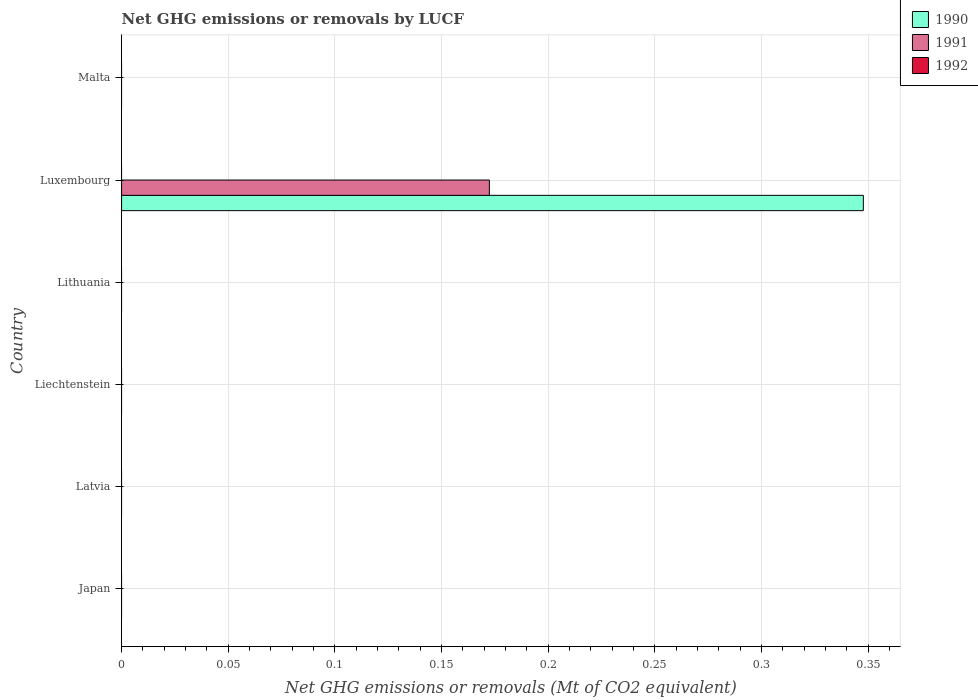Are the number of bars on each tick of the Y-axis equal?
Your response must be concise. No. How many bars are there on the 5th tick from the top?
Provide a short and direct response. 0. How many bars are there on the 6th tick from the bottom?
Keep it short and to the point. 0. What is the label of the 5th group of bars from the top?
Your answer should be compact. Latvia. In how many cases, is the number of bars for a given country not equal to the number of legend labels?
Your response must be concise. 6. What is the net GHG emissions or removals by LUCF in 1992 in Malta?
Your answer should be compact. 0. Across all countries, what is the maximum net GHG emissions or removals by LUCF in 1990?
Your answer should be very brief. 0.35. In which country was the net GHG emissions or removals by LUCF in 1990 maximum?
Your answer should be compact. Luxembourg. What is the total net GHG emissions or removals by LUCF in 1991 in the graph?
Provide a short and direct response. 0.17. What is the difference between the net GHG emissions or removals by LUCF in 1990 in Luxembourg and the net GHG emissions or removals by LUCF in 1992 in Malta?
Offer a very short reply. 0.35. What is the average net GHG emissions or removals by LUCF in 1990 per country?
Provide a short and direct response. 0.06. What is the difference between the highest and the lowest net GHG emissions or removals by LUCF in 1991?
Provide a succinct answer. 0.17. Is it the case that in every country, the sum of the net GHG emissions or removals by LUCF in 1991 and net GHG emissions or removals by LUCF in 1990 is greater than the net GHG emissions or removals by LUCF in 1992?
Your response must be concise. No. Does the graph contain grids?
Your answer should be very brief. Yes. What is the title of the graph?
Provide a succinct answer. Net GHG emissions or removals by LUCF. What is the label or title of the X-axis?
Provide a short and direct response. Net GHG emissions or removals (Mt of CO2 equivalent). What is the label or title of the Y-axis?
Your answer should be compact. Country. What is the Net GHG emissions or removals (Mt of CO2 equivalent) of 1992 in Japan?
Make the answer very short. 0. What is the Net GHG emissions or removals (Mt of CO2 equivalent) of 1992 in Latvia?
Your answer should be compact. 0. What is the Net GHG emissions or removals (Mt of CO2 equivalent) in 1990 in Liechtenstein?
Your response must be concise. 0. What is the Net GHG emissions or removals (Mt of CO2 equivalent) of 1992 in Liechtenstein?
Provide a succinct answer. 0. What is the Net GHG emissions or removals (Mt of CO2 equivalent) of 1991 in Lithuania?
Ensure brevity in your answer.  0. What is the Net GHG emissions or removals (Mt of CO2 equivalent) in 1992 in Lithuania?
Your answer should be compact. 0. What is the Net GHG emissions or removals (Mt of CO2 equivalent) in 1990 in Luxembourg?
Your answer should be compact. 0.35. What is the Net GHG emissions or removals (Mt of CO2 equivalent) in 1991 in Luxembourg?
Make the answer very short. 0.17. What is the Net GHG emissions or removals (Mt of CO2 equivalent) in 1990 in Malta?
Provide a short and direct response. 0. What is the Net GHG emissions or removals (Mt of CO2 equivalent) in 1991 in Malta?
Provide a short and direct response. 0. What is the Net GHG emissions or removals (Mt of CO2 equivalent) in 1992 in Malta?
Make the answer very short. 0. Across all countries, what is the maximum Net GHG emissions or removals (Mt of CO2 equivalent) in 1990?
Offer a terse response. 0.35. Across all countries, what is the maximum Net GHG emissions or removals (Mt of CO2 equivalent) in 1991?
Offer a very short reply. 0.17. Across all countries, what is the minimum Net GHG emissions or removals (Mt of CO2 equivalent) in 1990?
Offer a very short reply. 0. Across all countries, what is the minimum Net GHG emissions or removals (Mt of CO2 equivalent) in 1991?
Give a very brief answer. 0. What is the total Net GHG emissions or removals (Mt of CO2 equivalent) in 1990 in the graph?
Keep it short and to the point. 0.35. What is the total Net GHG emissions or removals (Mt of CO2 equivalent) of 1991 in the graph?
Your response must be concise. 0.17. What is the total Net GHG emissions or removals (Mt of CO2 equivalent) of 1992 in the graph?
Ensure brevity in your answer.  0. What is the average Net GHG emissions or removals (Mt of CO2 equivalent) in 1990 per country?
Your answer should be very brief. 0.06. What is the average Net GHG emissions or removals (Mt of CO2 equivalent) in 1991 per country?
Your response must be concise. 0.03. What is the difference between the Net GHG emissions or removals (Mt of CO2 equivalent) in 1990 and Net GHG emissions or removals (Mt of CO2 equivalent) in 1991 in Luxembourg?
Offer a terse response. 0.18. What is the difference between the highest and the lowest Net GHG emissions or removals (Mt of CO2 equivalent) in 1990?
Provide a succinct answer. 0.35. What is the difference between the highest and the lowest Net GHG emissions or removals (Mt of CO2 equivalent) of 1991?
Your answer should be very brief. 0.17. 